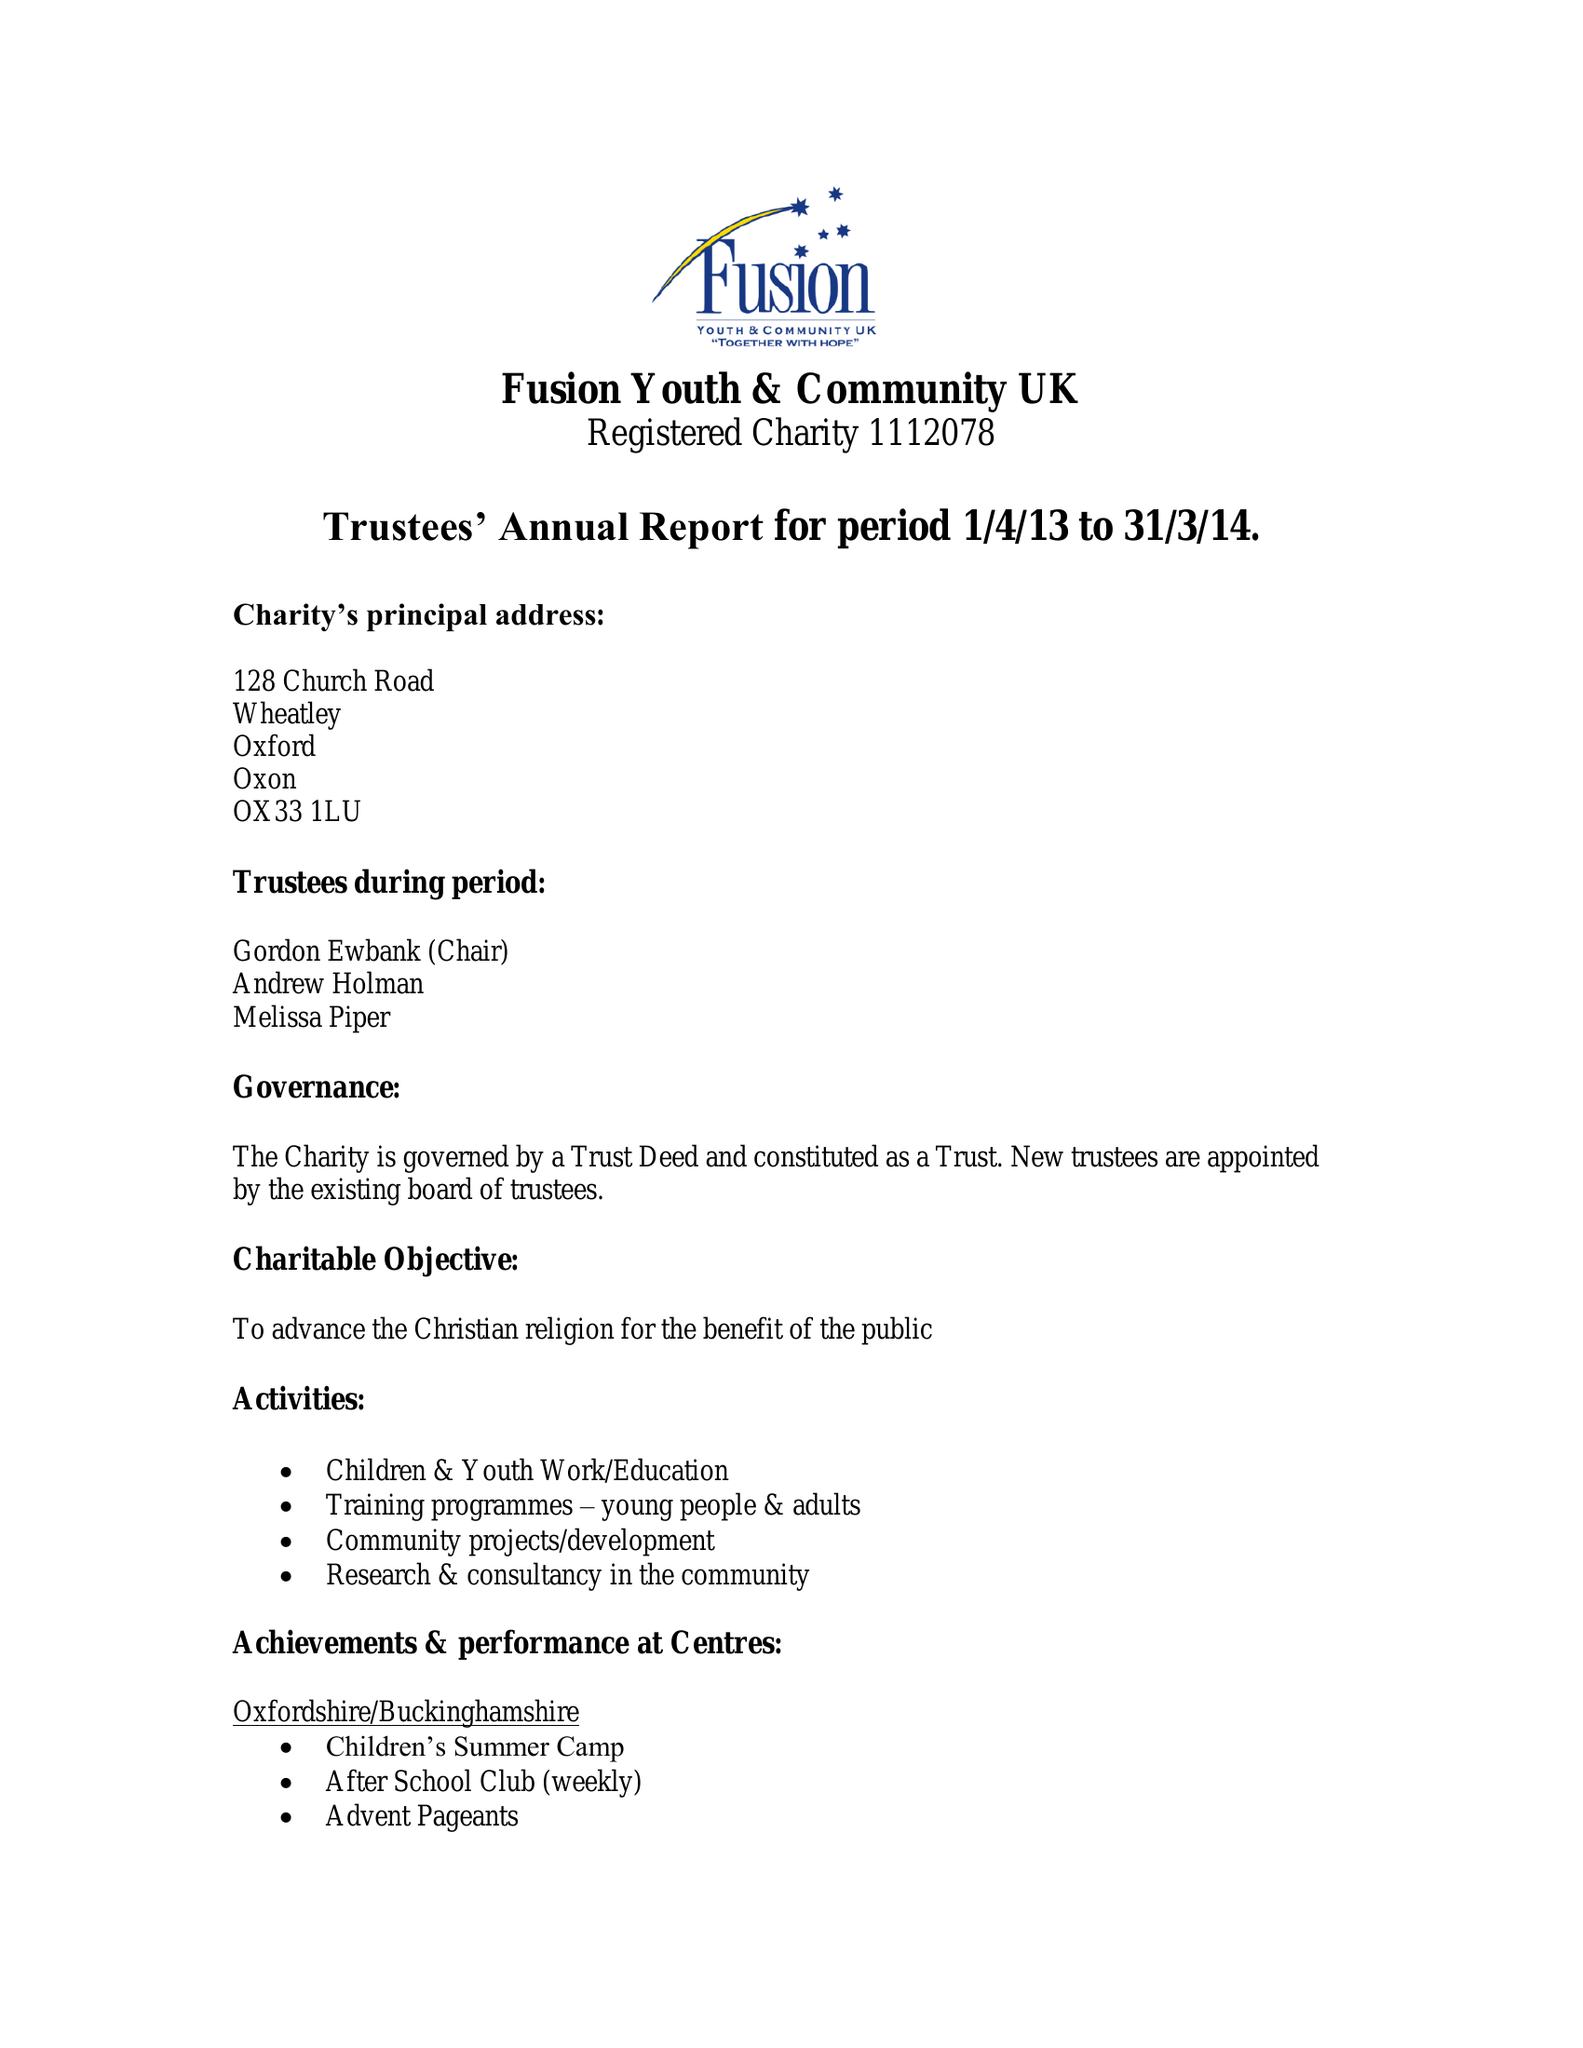What is the value for the spending_annually_in_british_pounds?
Answer the question using a single word or phrase. 81105.00 